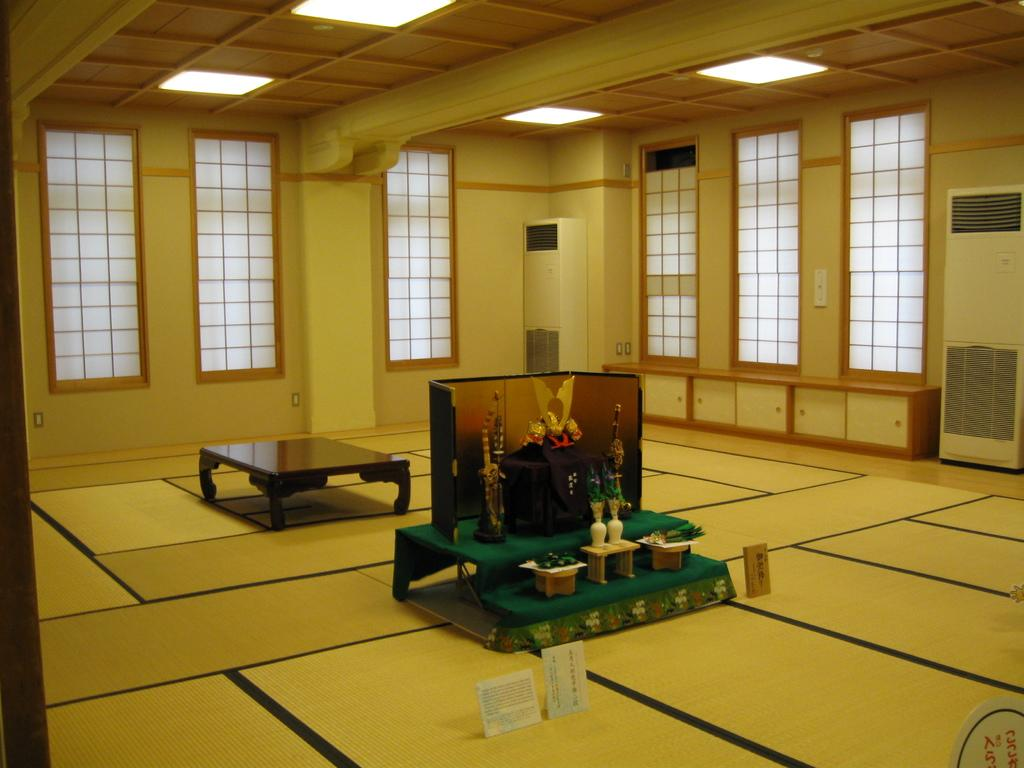What color is the wall that can be seen in the image? The wall in the image is yellow. What can be seen on the wall in the image? There are posters on the wall in the image. What type of openings are present in the image? There are windows in the image. What can be found in the image that provides illumination? There are lights in the image. What type of furniture is present in the image? There are tables in the image. What type of decorative items can be seen in the image? There are flower flasks in the image. What type of juice is being served in the image? There is no juice present in the image. What is the mother doing in the image? There is no mother or any person present in the image. 